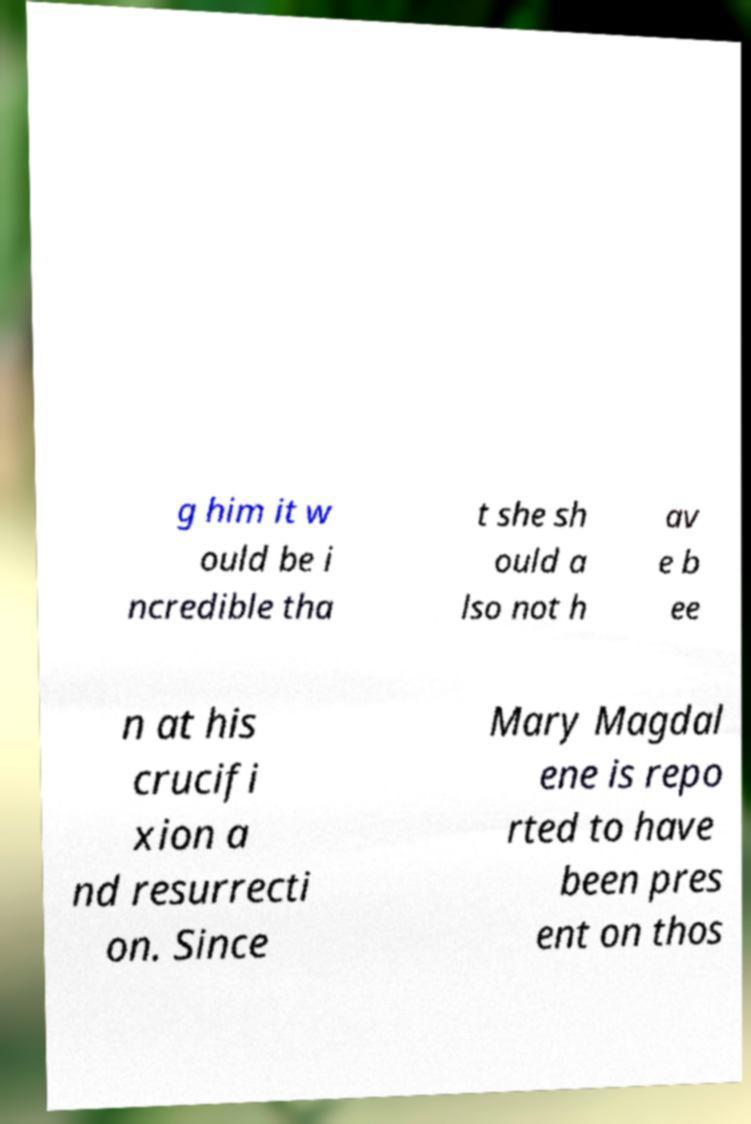Please read and relay the text visible in this image. What does it say? g him it w ould be i ncredible tha t she sh ould a lso not h av e b ee n at his crucifi xion a nd resurrecti on. Since Mary Magdal ene is repo rted to have been pres ent on thos 